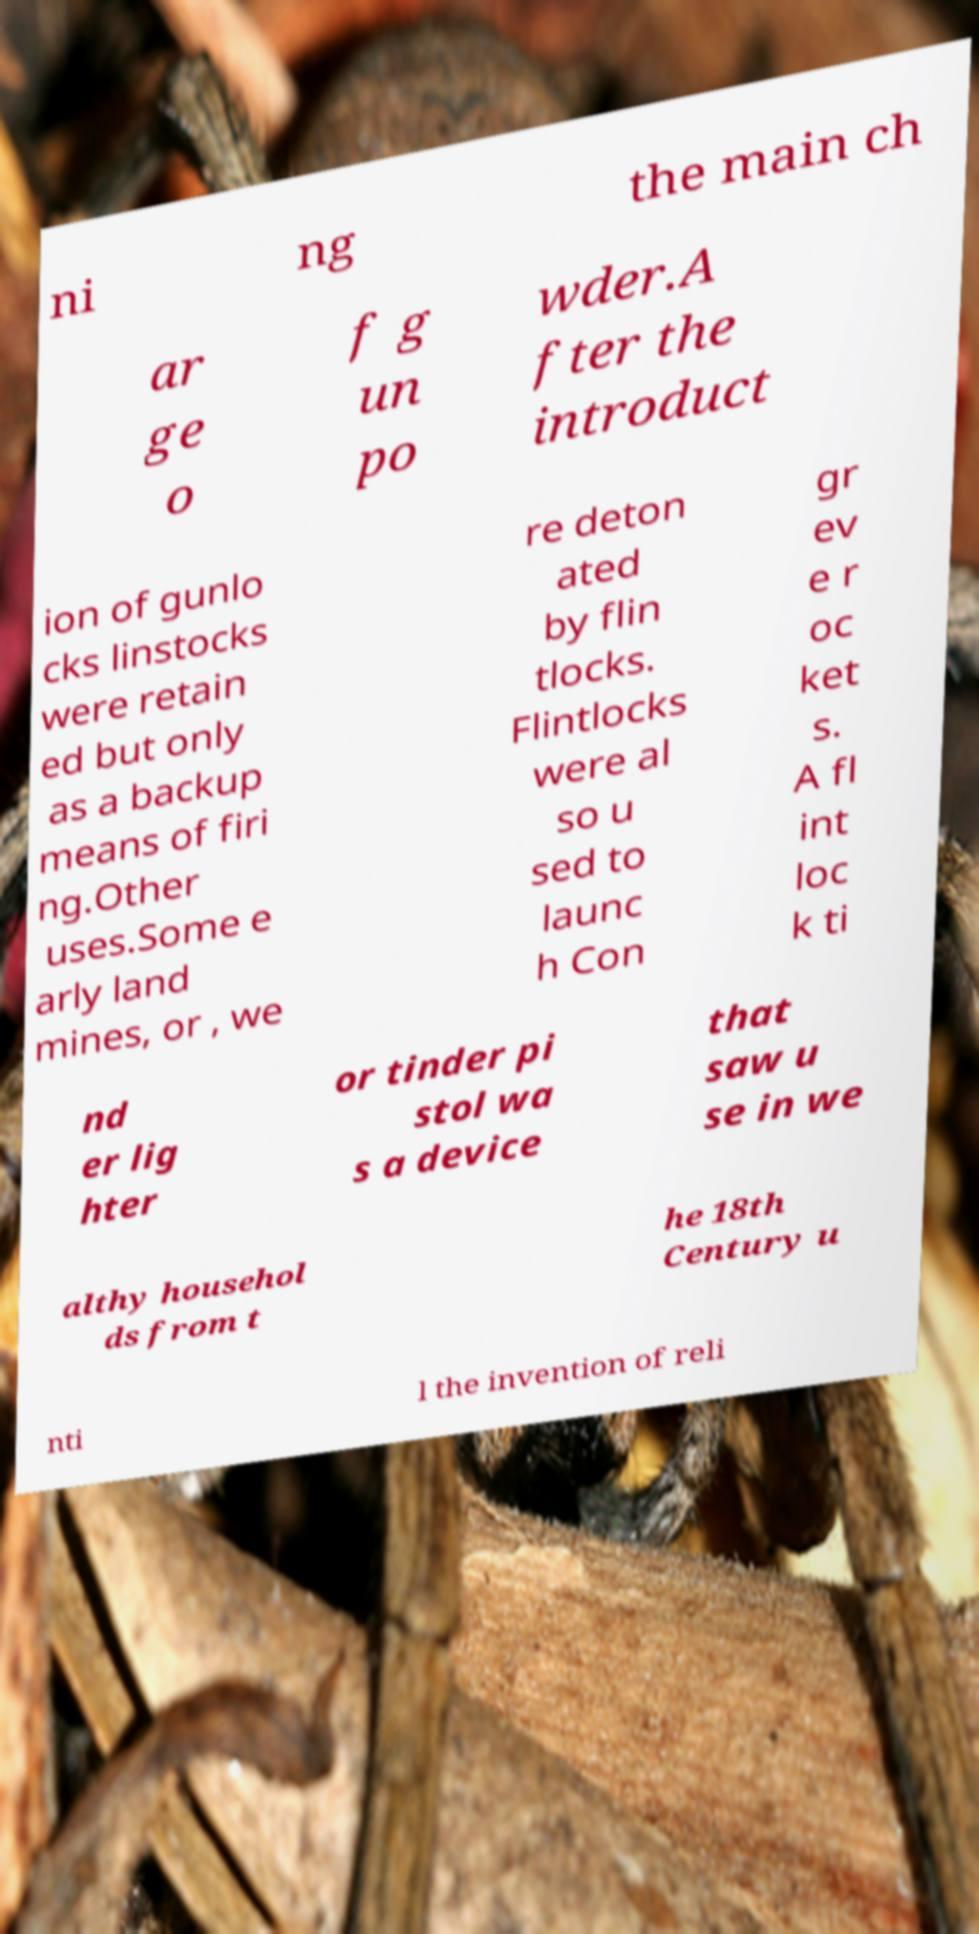Can you accurately transcribe the text from the provided image for me? ni ng the main ch ar ge o f g un po wder.A fter the introduct ion of gunlo cks linstocks were retain ed but only as a backup means of firi ng.Other uses.Some e arly land mines, or , we re deton ated by flin tlocks. Flintlocks were al so u sed to launc h Con gr ev e r oc ket s. A fl int loc k ti nd er lig hter or tinder pi stol wa s a device that saw u se in we althy househol ds from t he 18th Century u nti l the invention of reli 